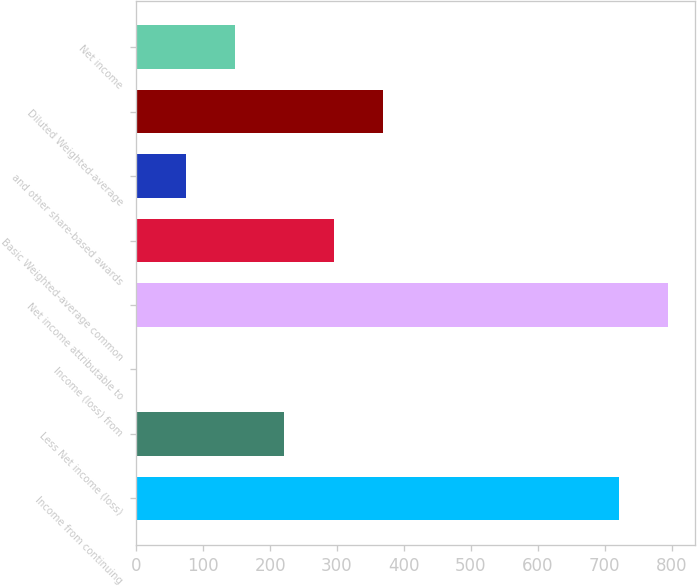<chart> <loc_0><loc_0><loc_500><loc_500><bar_chart><fcel>Income from continuing<fcel>Less Net income (loss)<fcel>Income (loss) from<fcel>Net income attributable to<fcel>Basic Weighted-average common<fcel>and other share-based awards<fcel>Diluted Weighted-average<fcel>Net income<nl><fcel>721<fcel>221.5<fcel>1<fcel>794.5<fcel>295<fcel>74.5<fcel>368.5<fcel>148<nl></chart> 